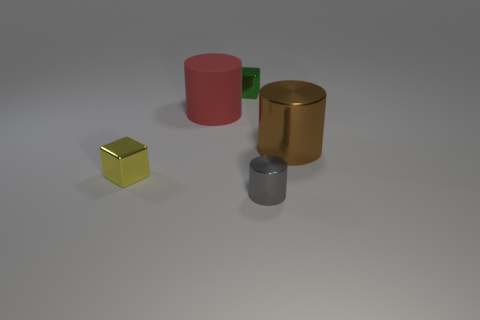Is there any other thing that is made of the same material as the big red cylinder?
Offer a terse response. No. What number of brown metal things are in front of the large object right of the big red cylinder?
Provide a short and direct response. 0. Does the object that is behind the red rubber thing have the same shape as the yellow thing?
Your answer should be compact. Yes. There is a red object that is the same shape as the tiny gray shiny object; what is it made of?
Keep it short and to the point. Rubber. How many rubber cylinders are the same size as the yellow object?
Make the answer very short. 0. What color is the metal object that is behind the small yellow object and to the left of the small gray thing?
Offer a very short reply. Green. Is the number of purple cubes less than the number of shiny things?
Your response must be concise. Yes. Is the number of small metal things that are behind the big brown object the same as the number of tiny blocks to the right of the red object?
Make the answer very short. Yes. What number of small yellow objects have the same shape as the green object?
Make the answer very short. 1. Are any brown things visible?
Offer a very short reply. Yes. 